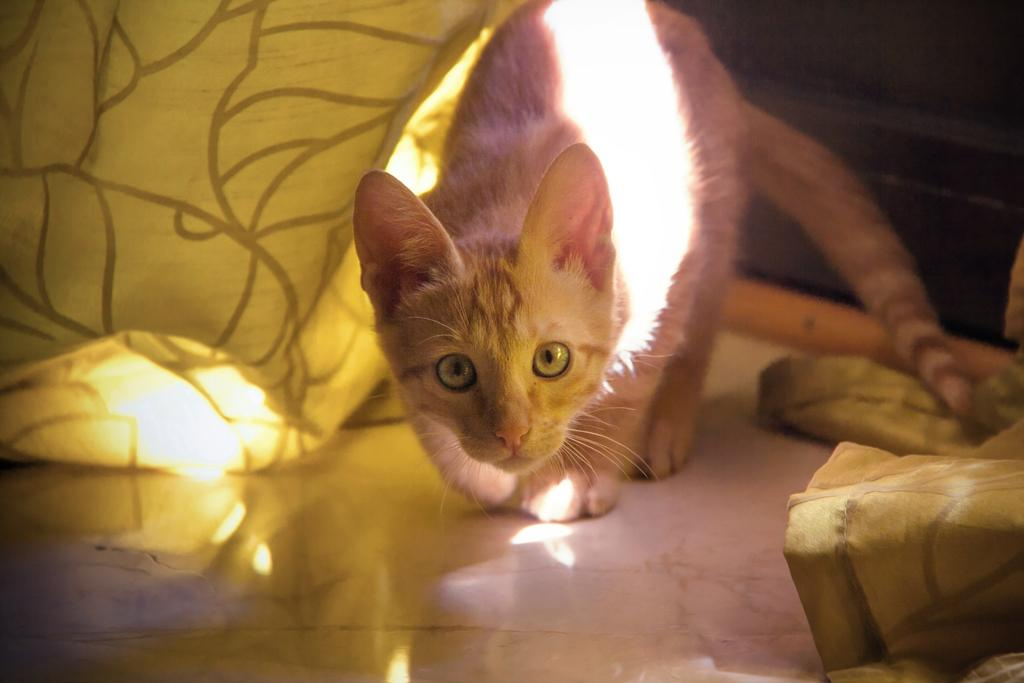What type of animal is in the image? There is a cat in the image. What color is the cat? The cat is white in color. Where is the cat located in the image? The cat is on the floor. What type of brass instrument is the cat playing in the image? There is no brass instrument present in the image, and the cat is not playing any instrument. 